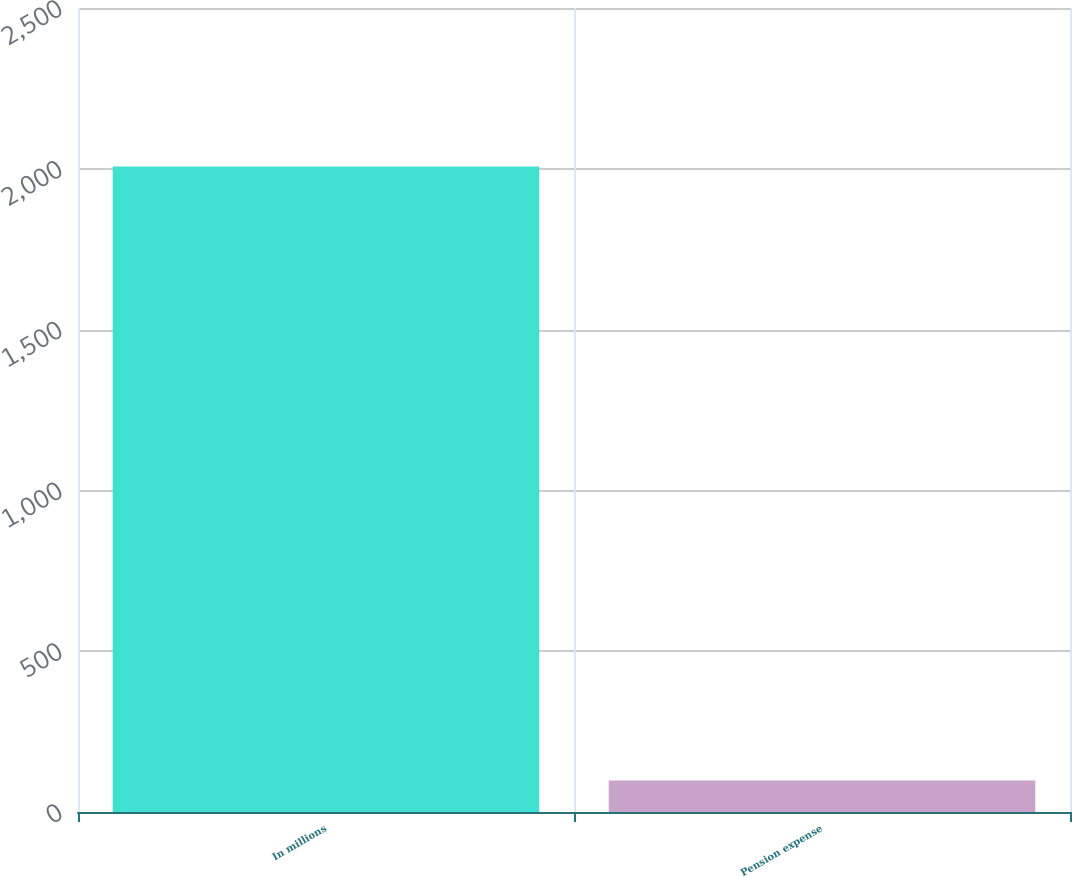Convert chart. <chart><loc_0><loc_0><loc_500><loc_500><bar_chart><fcel>In millions<fcel>Pension expense<nl><fcel>2007<fcel>98<nl></chart> 